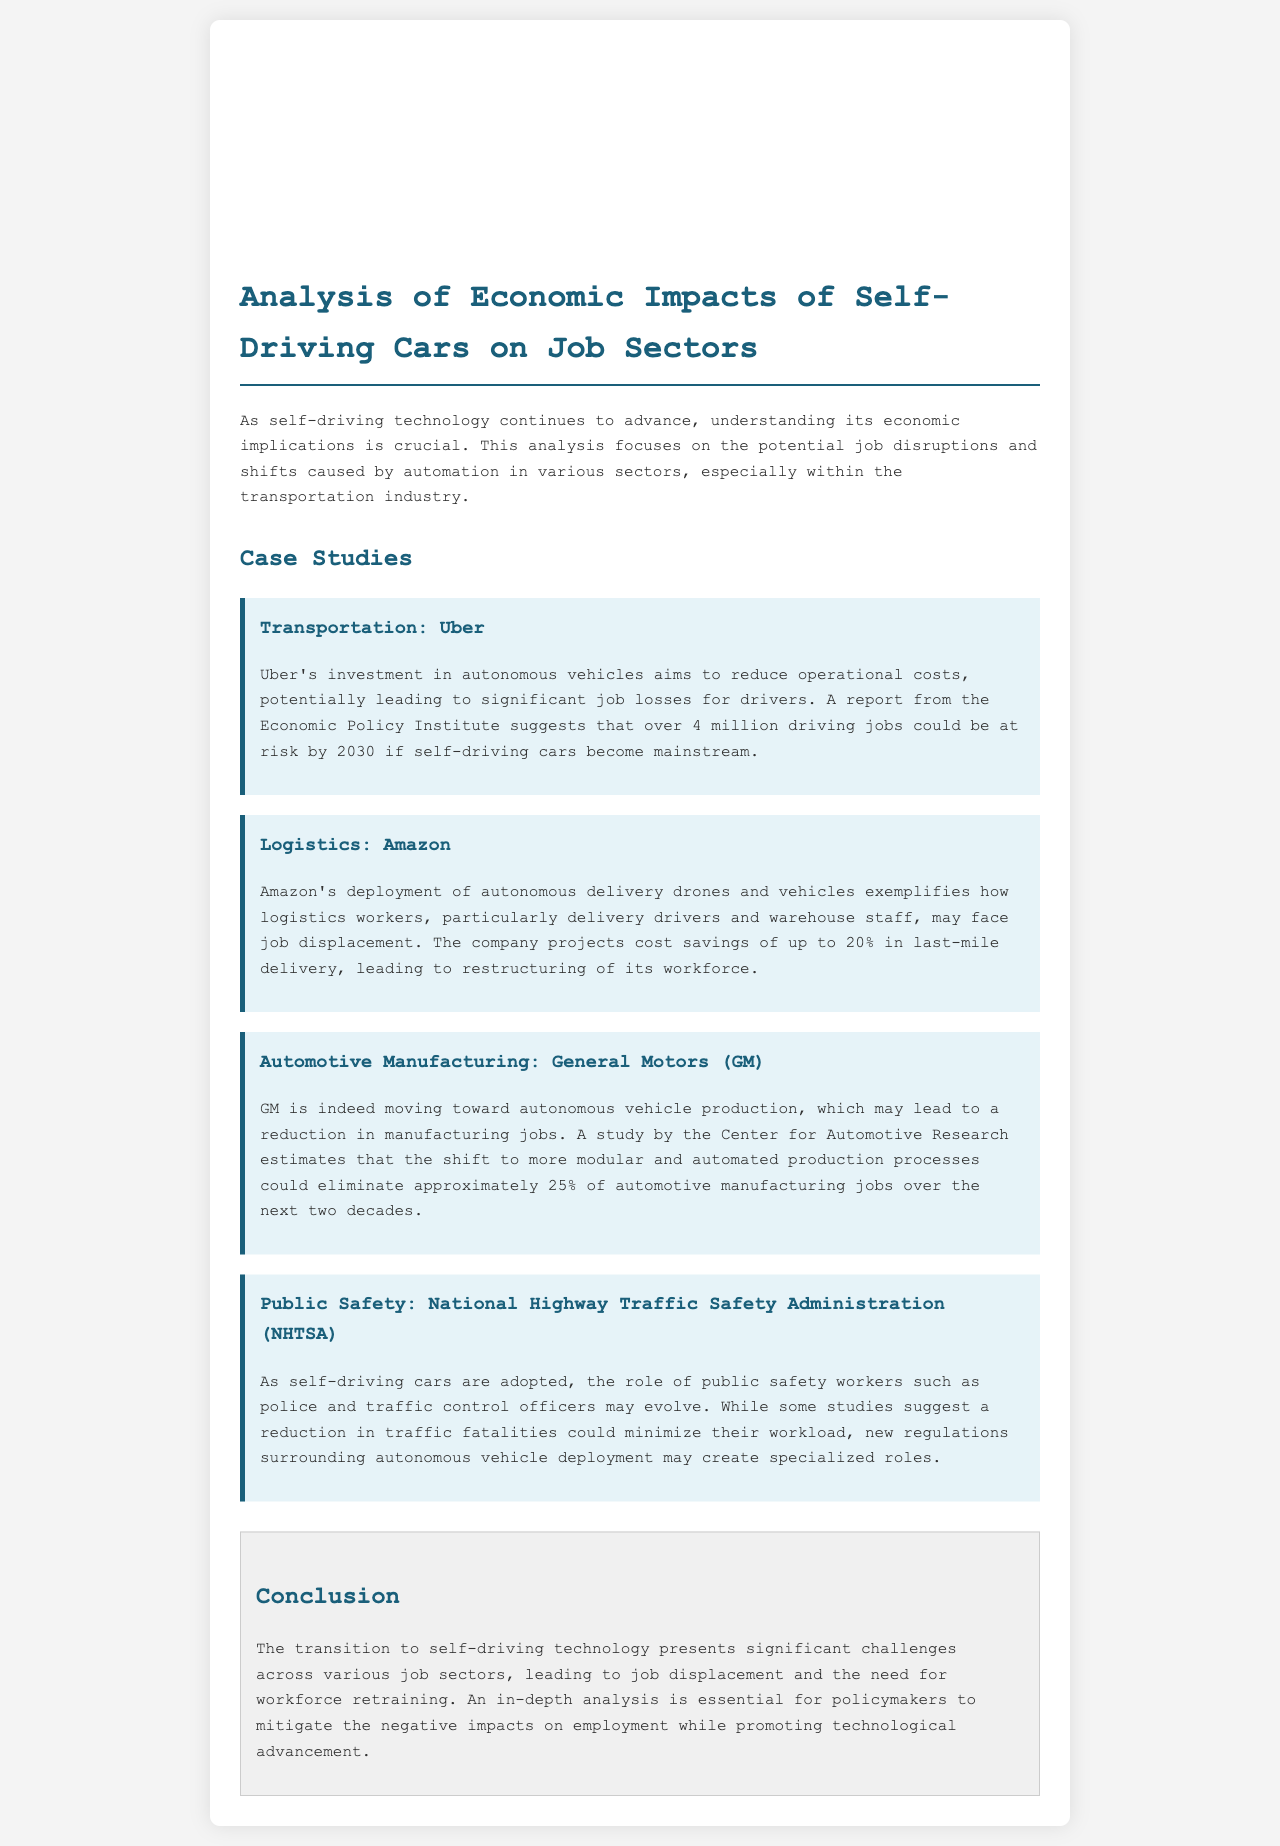What is the job risk for Uber drivers by 2030? The report from the Economic Policy Institute suggests that over 4 million driving jobs could be at risk by 2030 if self-driving cars become mainstream.
Answer: over 4 million What percentage of cost savings does Amazon project in last-mile delivery? Amazon projects cost savings of up to 20% in last-mile delivery, leading to restructuring of its workforce.
Answer: 20% What is the estimated job reduction in automotive manufacturing by GM? A study by the Center for Automotive Research estimates that the shift to more modular and automated production processes could eliminate approximately 25% of automotive manufacturing jobs over the next two decades.
Answer: 25% Which organization is mentioned in relation to public safety concerns? The document mentions the National Highway Traffic Safety Administration (NHTSA) in the context of public safety workers and evolving roles.
Answer: National Highway Traffic Safety Administration (NHTSA) What is a significant challenge presented by self-driving technology? The transition to self-driving technology presents significant challenges across various job sectors, leading to job displacement and the need for workforce retraining.
Answer: job displacement What could create specialized roles for public safety workers? New regulations surrounding autonomous vehicle deployment may create specialized roles for public safety workers as self-driving cars are adopted.
Answer: New regulations What type of document is this? The document is an analysis focusing on the economic impacts of self-driving cars on job sectors through detailed case studies.
Answer: analysis In which section are case studies included? Case studies are included in the section titled "Case Studies" in the document.
Answer: Case Studies 